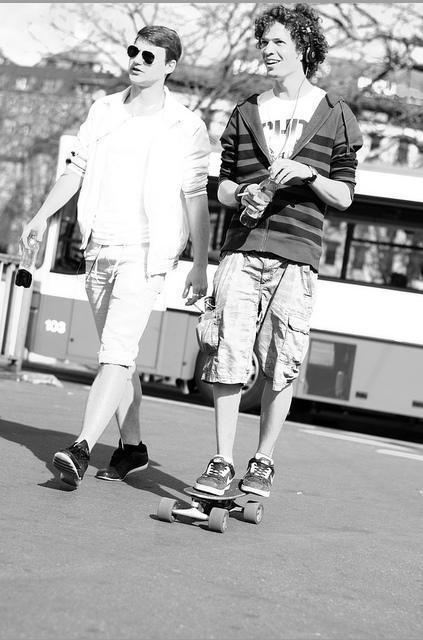How many people are in the photo?
Give a very brief answer. 2. 